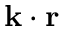Convert formula to latex. <formula><loc_0><loc_0><loc_500><loc_500>{ k } \cdot { r }</formula> 